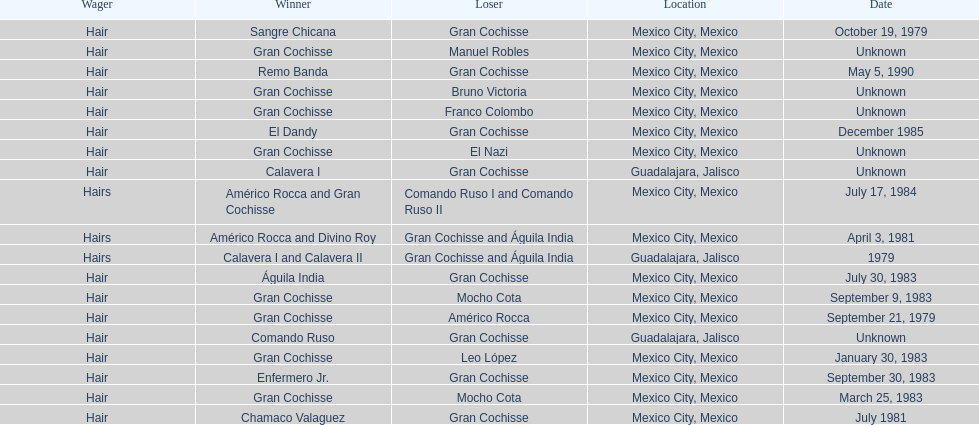How many times has the wager been hair? 16. 